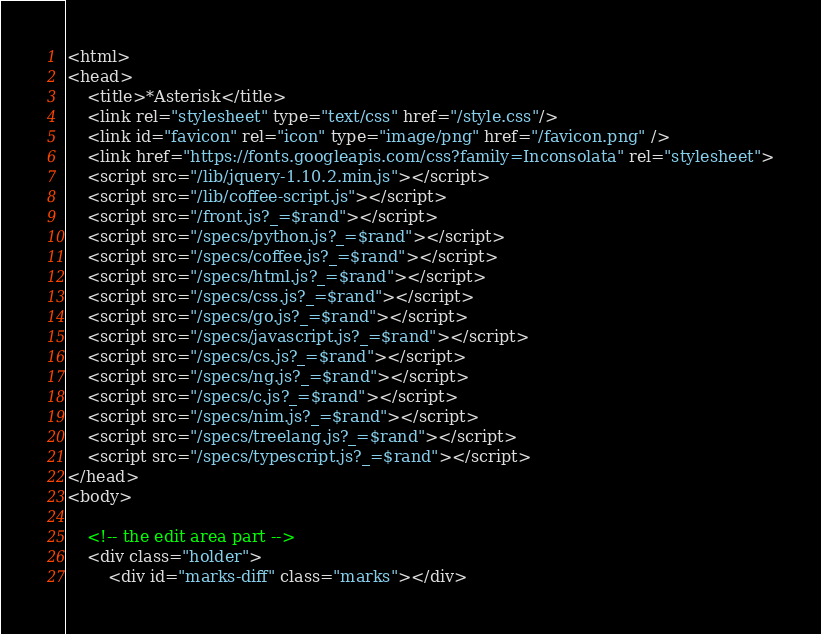Convert code to text. <code><loc_0><loc_0><loc_500><loc_500><_HTML_><html>
<head>
    <title>*Asterisk</title>
    <link rel="stylesheet" type="text/css" href="/style.css"/>
    <link id="favicon" rel="icon" type="image/png" href="/favicon.png" />
    <link href="https://fonts.googleapis.com/css?family=Inconsolata" rel="stylesheet">
    <script src="/lib/jquery-1.10.2.min.js"></script>
    <script src="/lib/coffee-script.js"></script>
    <script src="/front.js?_=$rand"></script>
    <script src="/specs/python.js?_=$rand"></script>
    <script src="/specs/coffee.js?_=$rand"></script>
    <script src="/specs/html.js?_=$rand"></script>
    <script src="/specs/css.js?_=$rand"></script>
    <script src="/specs/go.js?_=$rand"></script>
    <script src="/specs/javascript.js?_=$rand"></script>
    <script src="/specs/cs.js?_=$rand"></script>
    <script src="/specs/ng.js?_=$rand"></script>
    <script src="/specs/c.js?_=$rand"></script>
    <script src="/specs/nim.js?_=$rand"></script>
    <script src="/specs/treelang.js?_=$rand"></script>
    <script src="/specs/typescript.js?_=$rand"></script>
</head>
<body>

    <!-- the edit area part -->
    <div class="holder">
        <div id="marks-diff" class="marks"></div></code> 